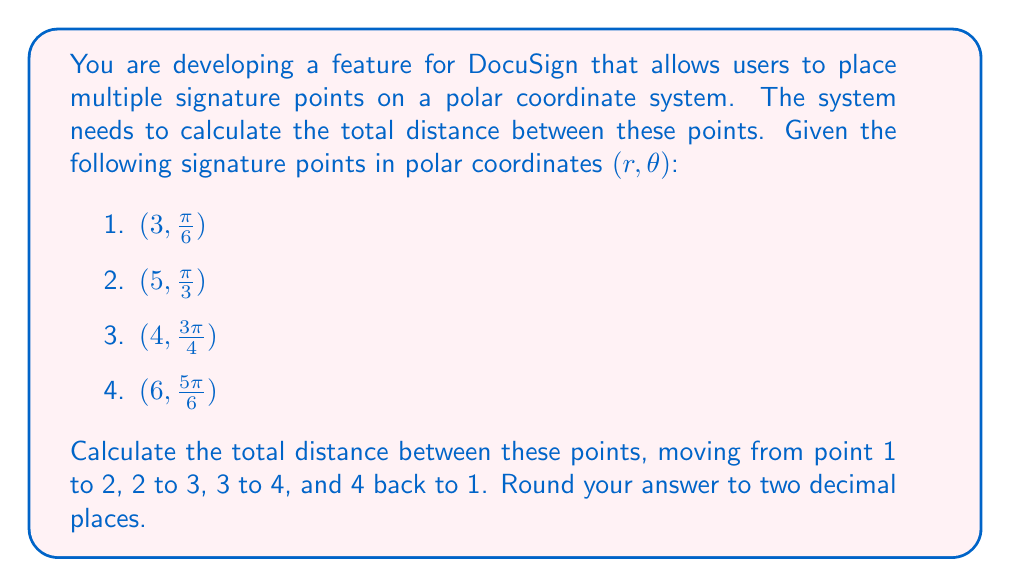Give your solution to this math problem. To solve this problem, we'll use the formula for the distance between two points in polar coordinates:

$$d = \sqrt{r_1^2 + r_2^2 - 2r_1r_2\cos(\theta_2 - \theta_1)}$$

Let's calculate the distance between each pair of points:

1. Distance from point 1 to point 2:
   $$d_{1,2} = \sqrt{3^2 + 5^2 - 2(3)(5)\cos(\frac{\pi}{3} - \frac{\pi}{6})} = \sqrt{34 - 30\cos(\frac{\pi}{6})} \approx 2.6458$$

2. Distance from point 2 to point 3:
   $$d_{2,3} = \sqrt{5^2 + 4^2 - 2(5)(4)\cos(\frac{3\pi}{4} - \frac{\pi}{3})} = \sqrt{41 - 40\cos(\frac{5\pi}{12})} \approx 4.2720$$

3. Distance from point 3 to point 4:
   $$d_{3,4} = \sqrt{4^2 + 6^2 - 2(4)(6)\cos(\frac{5\pi}{6} - \frac{3\pi}{4})} = \sqrt{52 - 48\cos(\frac{\pi}{12})} \approx 2.4495$$

4. Distance from point 4 back to point 1:
   $$d_{4,1} = \sqrt{6^2 + 3^2 - 2(6)(3)\cos(\frac{\pi}{6} - \frac{5\pi}{6})} = \sqrt{45 - 36\cos(\frac{2\pi}{3})} \approx 6.2450$$

Now, we sum up all these distances:

$$\text{Total distance} = d_{1,2} + d_{2,3} + d_{3,4} + d_{4,1}$$
$$\approx 2.6458 + 4.2720 + 2.4495 + 6.2450 = 15.6123$$

Rounding to two decimal places, we get 15.61.
Answer: 15.61 